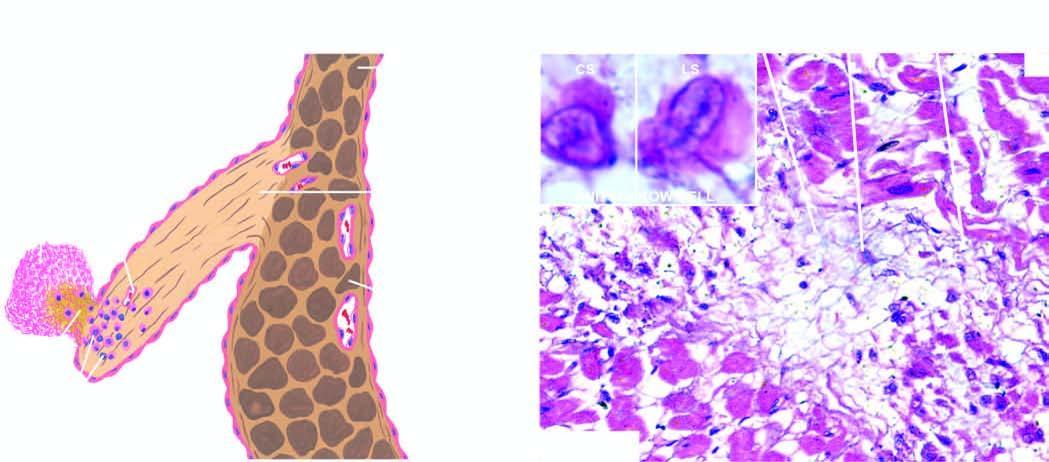what does inbox show in cross section and in longitudinal section?
Answer the question using a single word or phrase. An anitschkow cell 